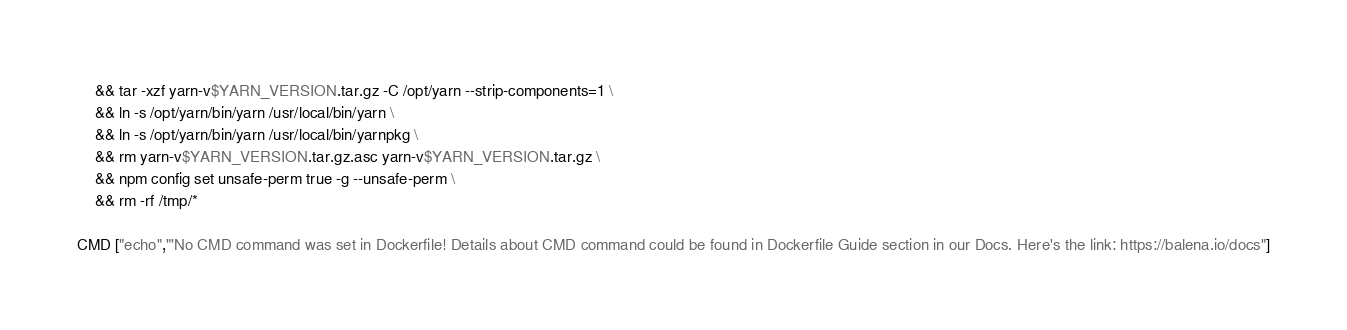<code> <loc_0><loc_0><loc_500><loc_500><_Dockerfile_>	&& tar -xzf yarn-v$YARN_VERSION.tar.gz -C /opt/yarn --strip-components=1 \
	&& ln -s /opt/yarn/bin/yarn /usr/local/bin/yarn \
	&& ln -s /opt/yarn/bin/yarn /usr/local/bin/yarnpkg \
	&& rm yarn-v$YARN_VERSION.tar.gz.asc yarn-v$YARN_VERSION.tar.gz \
	&& npm config set unsafe-perm true -g --unsafe-perm \
	&& rm -rf /tmp/*

CMD ["echo","'No CMD command was set in Dockerfile! Details about CMD command could be found in Dockerfile Guide section in our Docs. Here's the link: https://balena.io/docs"]</code> 